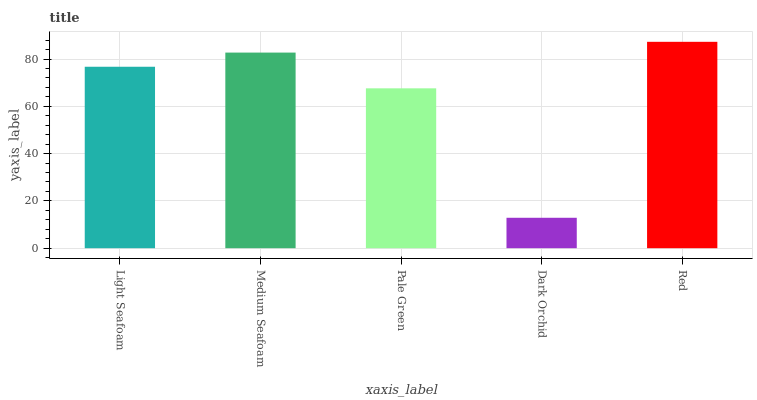Is Dark Orchid the minimum?
Answer yes or no. Yes. Is Red the maximum?
Answer yes or no. Yes. Is Medium Seafoam the minimum?
Answer yes or no. No. Is Medium Seafoam the maximum?
Answer yes or no. No. Is Medium Seafoam greater than Light Seafoam?
Answer yes or no. Yes. Is Light Seafoam less than Medium Seafoam?
Answer yes or no. Yes. Is Light Seafoam greater than Medium Seafoam?
Answer yes or no. No. Is Medium Seafoam less than Light Seafoam?
Answer yes or no. No. Is Light Seafoam the high median?
Answer yes or no. Yes. Is Light Seafoam the low median?
Answer yes or no. Yes. Is Red the high median?
Answer yes or no. No. Is Medium Seafoam the low median?
Answer yes or no. No. 